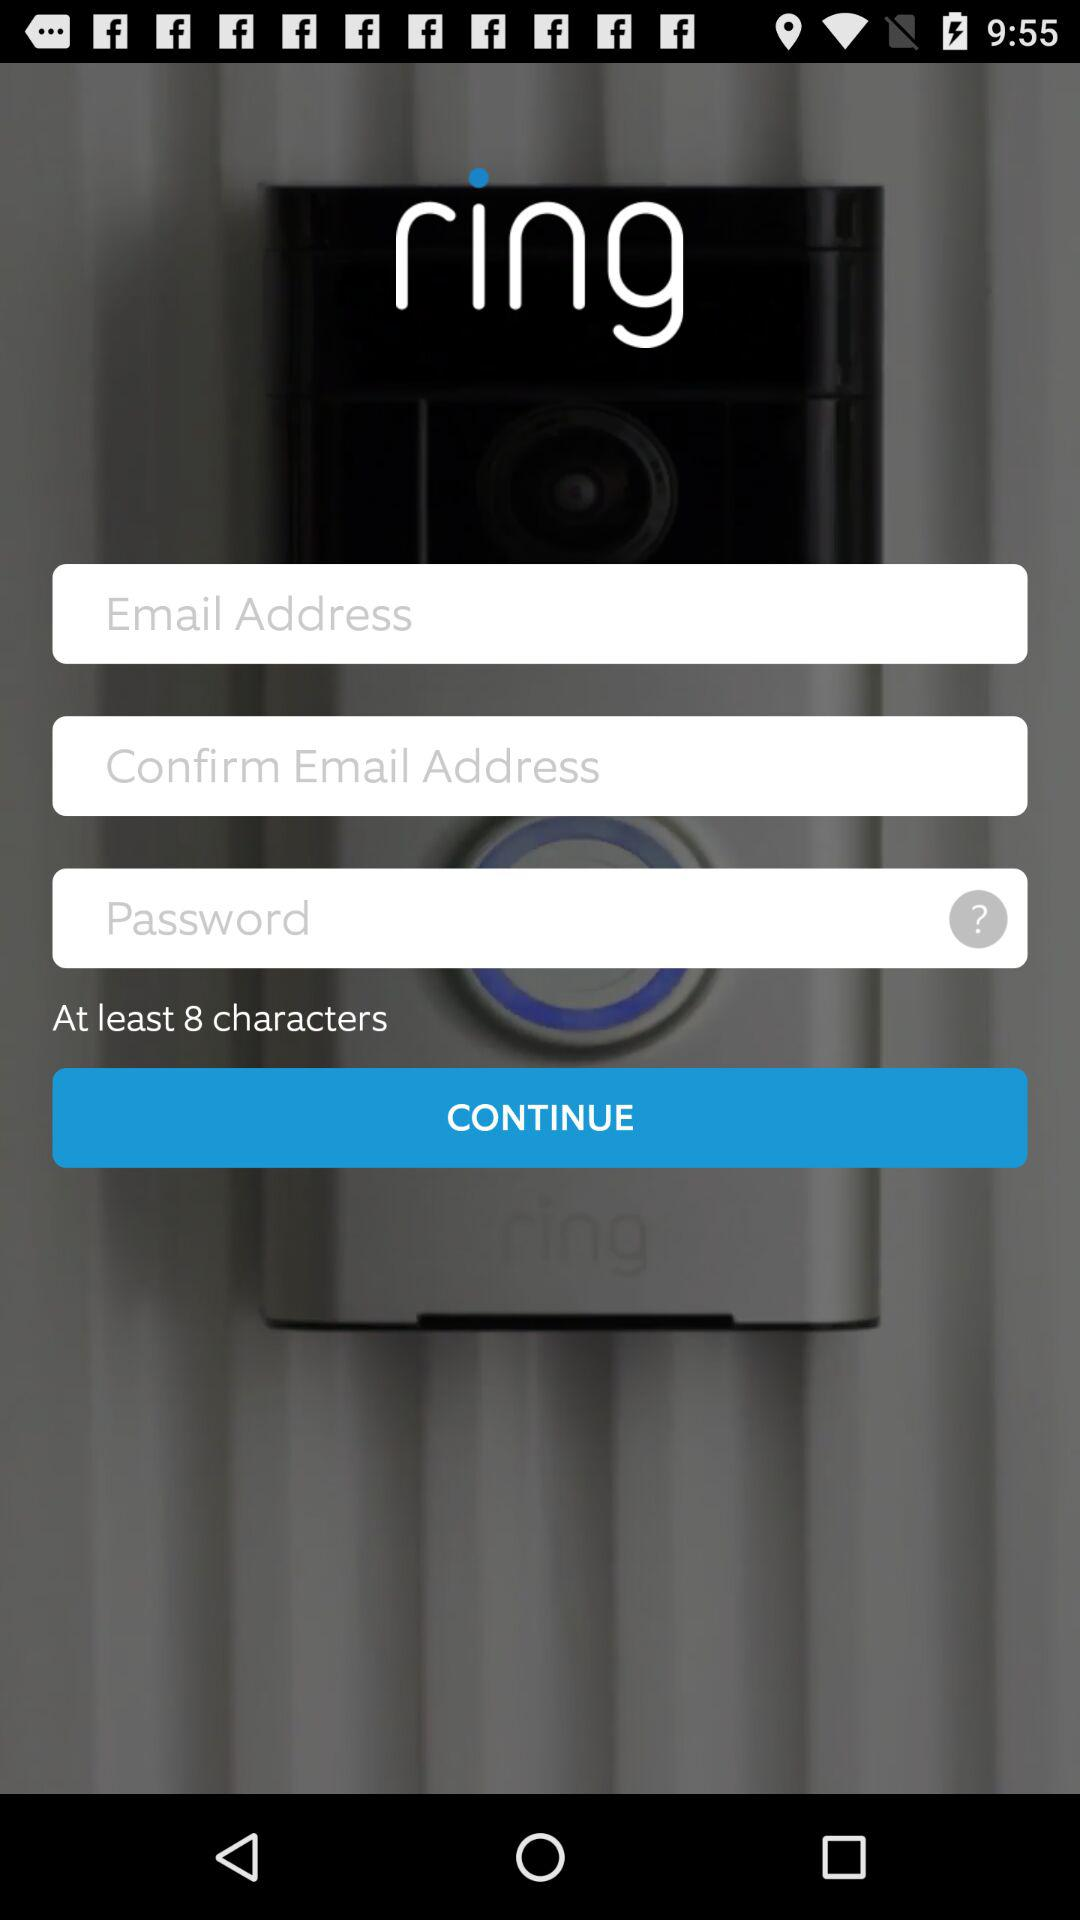What is the entered email address?
When the provided information is insufficient, respond with <no answer>. <no answer> 